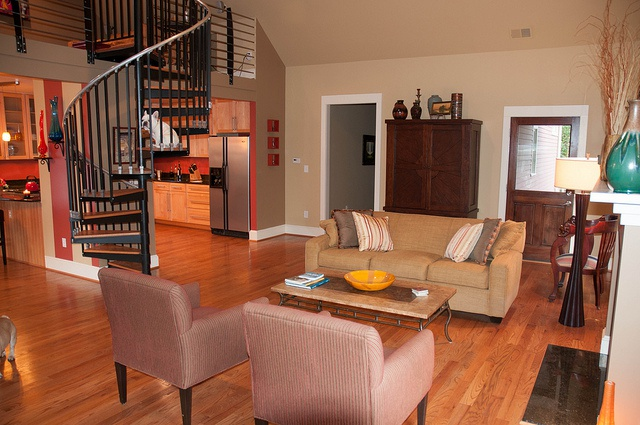Describe the objects in this image and their specific colors. I can see chair in maroon, brown, tan, and salmon tones, chair in maroon and brown tones, couch in maroon, tan, and brown tones, refrigerator in maroon, brown, black, and salmon tones, and chair in maroon, black, brown, and gray tones in this image. 